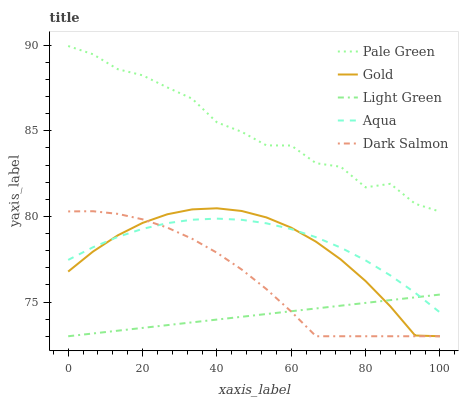Does Light Green have the minimum area under the curve?
Answer yes or no. Yes. Does Pale Green have the maximum area under the curve?
Answer yes or no. Yes. Does Aqua have the minimum area under the curve?
Answer yes or no. No. Does Aqua have the maximum area under the curve?
Answer yes or no. No. Is Light Green the smoothest?
Answer yes or no. Yes. Is Pale Green the roughest?
Answer yes or no. Yes. Is Aqua the smoothest?
Answer yes or no. No. Is Aqua the roughest?
Answer yes or no. No. Does Light Green have the lowest value?
Answer yes or no. Yes. Does Aqua have the lowest value?
Answer yes or no. No. Does Pale Green have the highest value?
Answer yes or no. Yes. Does Aqua have the highest value?
Answer yes or no. No. Is Aqua less than Pale Green?
Answer yes or no. Yes. Is Pale Green greater than Gold?
Answer yes or no. Yes. Does Light Green intersect Gold?
Answer yes or no. Yes. Is Light Green less than Gold?
Answer yes or no. No. Is Light Green greater than Gold?
Answer yes or no. No. Does Aqua intersect Pale Green?
Answer yes or no. No. 